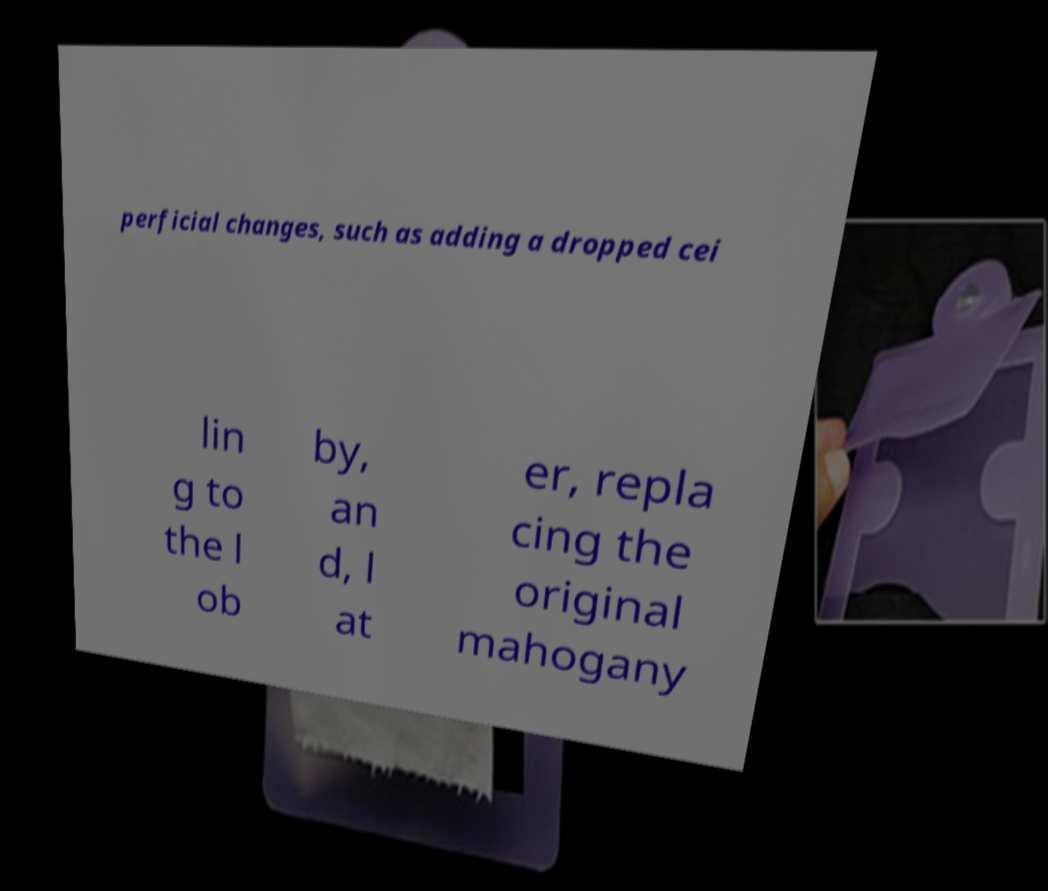For documentation purposes, I need the text within this image transcribed. Could you provide that? perficial changes, such as adding a dropped cei lin g to the l ob by, an d, l at er, repla cing the original mahogany 